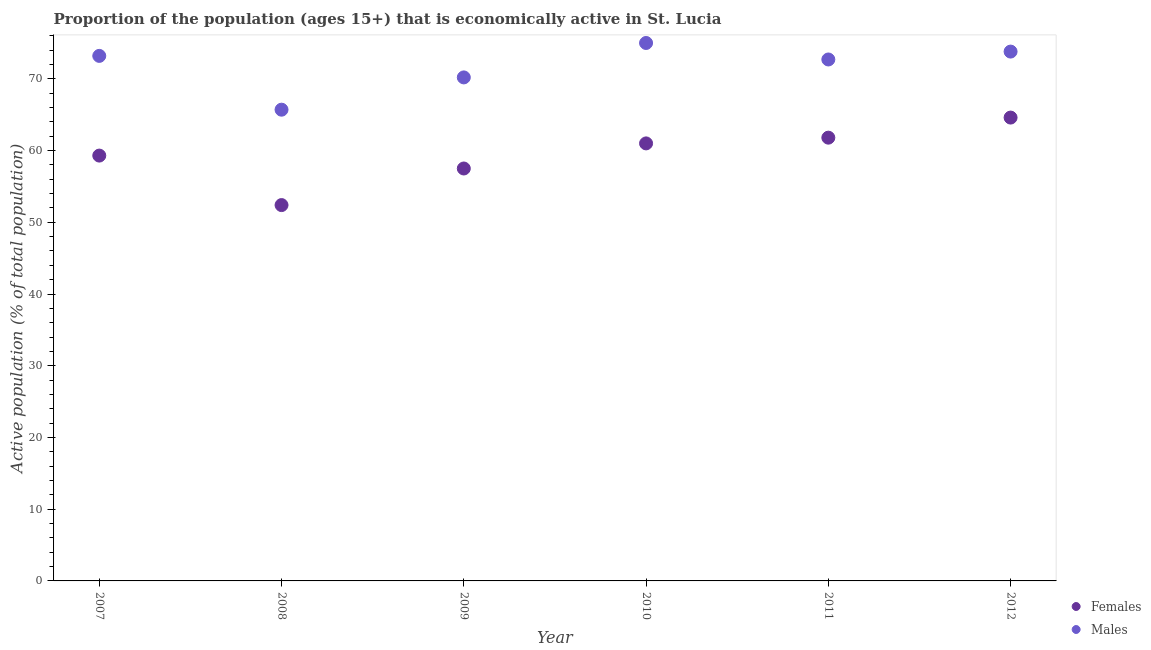How many different coloured dotlines are there?
Ensure brevity in your answer.  2. Is the number of dotlines equal to the number of legend labels?
Offer a very short reply. Yes. What is the percentage of economically active male population in 2007?
Your answer should be compact. 73.2. Across all years, what is the maximum percentage of economically active male population?
Keep it short and to the point. 75. Across all years, what is the minimum percentage of economically active female population?
Your answer should be compact. 52.4. What is the total percentage of economically active female population in the graph?
Provide a succinct answer. 356.6. What is the difference between the percentage of economically active male population in 2009 and that in 2012?
Make the answer very short. -3.6. What is the difference between the percentage of economically active male population in 2011 and the percentage of economically active female population in 2009?
Your response must be concise. 15.2. What is the average percentage of economically active male population per year?
Your response must be concise. 71.77. In the year 2009, what is the difference between the percentage of economically active male population and percentage of economically active female population?
Your answer should be compact. 12.7. In how many years, is the percentage of economically active male population greater than 16 %?
Ensure brevity in your answer.  6. What is the ratio of the percentage of economically active male population in 2010 to that in 2012?
Your answer should be very brief. 1.02. Is the percentage of economically active male population in 2009 less than that in 2012?
Offer a very short reply. Yes. Is the difference between the percentage of economically active male population in 2007 and 2011 greater than the difference between the percentage of economically active female population in 2007 and 2011?
Keep it short and to the point. Yes. What is the difference between the highest and the second highest percentage of economically active female population?
Ensure brevity in your answer.  2.8. What is the difference between the highest and the lowest percentage of economically active female population?
Provide a short and direct response. 12.2. Is the sum of the percentage of economically active male population in 2007 and 2011 greater than the maximum percentage of economically active female population across all years?
Offer a terse response. Yes. Does the percentage of economically active male population monotonically increase over the years?
Keep it short and to the point. No. Is the percentage of economically active male population strictly less than the percentage of economically active female population over the years?
Your response must be concise. No. How many dotlines are there?
Make the answer very short. 2. How many years are there in the graph?
Make the answer very short. 6. What is the difference between two consecutive major ticks on the Y-axis?
Give a very brief answer. 10. Are the values on the major ticks of Y-axis written in scientific E-notation?
Provide a succinct answer. No. Does the graph contain grids?
Keep it short and to the point. No. How are the legend labels stacked?
Offer a very short reply. Vertical. What is the title of the graph?
Provide a succinct answer. Proportion of the population (ages 15+) that is economically active in St. Lucia. What is the label or title of the Y-axis?
Provide a short and direct response. Active population (% of total population). What is the Active population (% of total population) in Females in 2007?
Offer a terse response. 59.3. What is the Active population (% of total population) of Males in 2007?
Your response must be concise. 73.2. What is the Active population (% of total population) of Females in 2008?
Offer a very short reply. 52.4. What is the Active population (% of total population) in Males in 2008?
Give a very brief answer. 65.7. What is the Active population (% of total population) in Females in 2009?
Your answer should be compact. 57.5. What is the Active population (% of total population) of Males in 2009?
Offer a very short reply. 70.2. What is the Active population (% of total population) of Females in 2010?
Provide a short and direct response. 61. What is the Active population (% of total population) in Females in 2011?
Offer a terse response. 61.8. What is the Active population (% of total population) of Males in 2011?
Provide a succinct answer. 72.7. What is the Active population (% of total population) of Females in 2012?
Provide a succinct answer. 64.6. What is the Active population (% of total population) in Males in 2012?
Your answer should be very brief. 73.8. Across all years, what is the maximum Active population (% of total population) in Females?
Provide a succinct answer. 64.6. Across all years, what is the minimum Active population (% of total population) of Females?
Offer a very short reply. 52.4. Across all years, what is the minimum Active population (% of total population) in Males?
Make the answer very short. 65.7. What is the total Active population (% of total population) of Females in the graph?
Your response must be concise. 356.6. What is the total Active population (% of total population) in Males in the graph?
Provide a succinct answer. 430.6. What is the difference between the Active population (% of total population) in Females in 2007 and that in 2008?
Make the answer very short. 6.9. What is the difference between the Active population (% of total population) in Females in 2007 and that in 2009?
Keep it short and to the point. 1.8. What is the difference between the Active population (% of total population) in Females in 2007 and that in 2010?
Your answer should be very brief. -1.7. What is the difference between the Active population (% of total population) in Males in 2007 and that in 2010?
Your answer should be compact. -1.8. What is the difference between the Active population (% of total population) in Females in 2007 and that in 2011?
Your response must be concise. -2.5. What is the difference between the Active population (% of total population) of Males in 2007 and that in 2011?
Provide a succinct answer. 0.5. What is the difference between the Active population (% of total population) in Females in 2007 and that in 2012?
Offer a very short reply. -5.3. What is the difference between the Active population (% of total population) in Females in 2008 and that in 2009?
Your answer should be very brief. -5.1. What is the difference between the Active population (% of total population) in Females in 2008 and that in 2010?
Give a very brief answer. -8.6. What is the difference between the Active population (% of total population) of Females in 2008 and that in 2011?
Your response must be concise. -9.4. What is the difference between the Active population (% of total population) in Males in 2009 and that in 2010?
Your answer should be very brief. -4.8. What is the difference between the Active population (% of total population) of Females in 2009 and that in 2011?
Provide a succinct answer. -4.3. What is the difference between the Active population (% of total population) in Females in 2009 and that in 2012?
Give a very brief answer. -7.1. What is the difference between the Active population (% of total population) of Females in 2010 and that in 2011?
Ensure brevity in your answer.  -0.8. What is the difference between the Active population (% of total population) in Males in 2010 and that in 2012?
Provide a short and direct response. 1.2. What is the difference between the Active population (% of total population) of Females in 2011 and that in 2012?
Provide a short and direct response. -2.8. What is the difference between the Active population (% of total population) of Females in 2007 and the Active population (% of total population) of Males in 2008?
Your response must be concise. -6.4. What is the difference between the Active population (% of total population) in Females in 2007 and the Active population (% of total population) in Males in 2010?
Offer a very short reply. -15.7. What is the difference between the Active population (% of total population) in Females in 2008 and the Active population (% of total population) in Males in 2009?
Keep it short and to the point. -17.8. What is the difference between the Active population (% of total population) of Females in 2008 and the Active population (% of total population) of Males in 2010?
Ensure brevity in your answer.  -22.6. What is the difference between the Active population (% of total population) in Females in 2008 and the Active population (% of total population) in Males in 2011?
Give a very brief answer. -20.3. What is the difference between the Active population (% of total population) in Females in 2008 and the Active population (% of total population) in Males in 2012?
Your answer should be compact. -21.4. What is the difference between the Active population (% of total population) of Females in 2009 and the Active population (% of total population) of Males in 2010?
Keep it short and to the point. -17.5. What is the difference between the Active population (% of total population) in Females in 2009 and the Active population (% of total population) in Males in 2011?
Your answer should be compact. -15.2. What is the difference between the Active population (% of total population) of Females in 2009 and the Active population (% of total population) of Males in 2012?
Ensure brevity in your answer.  -16.3. What is the difference between the Active population (% of total population) in Females in 2010 and the Active population (% of total population) in Males in 2012?
Ensure brevity in your answer.  -12.8. What is the difference between the Active population (% of total population) in Females in 2011 and the Active population (% of total population) in Males in 2012?
Your answer should be very brief. -12. What is the average Active population (% of total population) of Females per year?
Keep it short and to the point. 59.43. What is the average Active population (% of total population) of Males per year?
Your answer should be compact. 71.77. In the year 2008, what is the difference between the Active population (% of total population) in Females and Active population (% of total population) in Males?
Ensure brevity in your answer.  -13.3. In the year 2010, what is the difference between the Active population (% of total population) in Females and Active population (% of total population) in Males?
Provide a succinct answer. -14. What is the ratio of the Active population (% of total population) in Females in 2007 to that in 2008?
Your response must be concise. 1.13. What is the ratio of the Active population (% of total population) of Males in 2007 to that in 2008?
Your answer should be very brief. 1.11. What is the ratio of the Active population (% of total population) of Females in 2007 to that in 2009?
Give a very brief answer. 1.03. What is the ratio of the Active population (% of total population) of Males in 2007 to that in 2009?
Ensure brevity in your answer.  1.04. What is the ratio of the Active population (% of total population) of Females in 2007 to that in 2010?
Ensure brevity in your answer.  0.97. What is the ratio of the Active population (% of total population) of Males in 2007 to that in 2010?
Offer a very short reply. 0.98. What is the ratio of the Active population (% of total population) in Females in 2007 to that in 2011?
Give a very brief answer. 0.96. What is the ratio of the Active population (% of total population) in Females in 2007 to that in 2012?
Your answer should be very brief. 0.92. What is the ratio of the Active population (% of total population) in Males in 2007 to that in 2012?
Keep it short and to the point. 0.99. What is the ratio of the Active population (% of total population) in Females in 2008 to that in 2009?
Make the answer very short. 0.91. What is the ratio of the Active population (% of total population) of Males in 2008 to that in 2009?
Provide a short and direct response. 0.94. What is the ratio of the Active population (% of total population) of Females in 2008 to that in 2010?
Keep it short and to the point. 0.86. What is the ratio of the Active population (% of total population) of Males in 2008 to that in 2010?
Offer a terse response. 0.88. What is the ratio of the Active population (% of total population) in Females in 2008 to that in 2011?
Offer a very short reply. 0.85. What is the ratio of the Active population (% of total population) in Males in 2008 to that in 2011?
Keep it short and to the point. 0.9. What is the ratio of the Active population (% of total population) of Females in 2008 to that in 2012?
Provide a short and direct response. 0.81. What is the ratio of the Active population (% of total population) in Males in 2008 to that in 2012?
Your answer should be very brief. 0.89. What is the ratio of the Active population (% of total population) in Females in 2009 to that in 2010?
Make the answer very short. 0.94. What is the ratio of the Active population (% of total population) in Males in 2009 to that in 2010?
Provide a succinct answer. 0.94. What is the ratio of the Active population (% of total population) in Females in 2009 to that in 2011?
Your answer should be compact. 0.93. What is the ratio of the Active population (% of total population) in Males in 2009 to that in 2011?
Ensure brevity in your answer.  0.97. What is the ratio of the Active population (% of total population) of Females in 2009 to that in 2012?
Provide a short and direct response. 0.89. What is the ratio of the Active population (% of total population) in Males in 2009 to that in 2012?
Your response must be concise. 0.95. What is the ratio of the Active population (% of total population) of Females in 2010 to that in 2011?
Keep it short and to the point. 0.99. What is the ratio of the Active population (% of total population) in Males in 2010 to that in 2011?
Provide a short and direct response. 1.03. What is the ratio of the Active population (% of total population) of Females in 2010 to that in 2012?
Your answer should be compact. 0.94. What is the ratio of the Active population (% of total population) of Males in 2010 to that in 2012?
Your answer should be compact. 1.02. What is the ratio of the Active population (% of total population) in Females in 2011 to that in 2012?
Offer a terse response. 0.96. What is the ratio of the Active population (% of total population) in Males in 2011 to that in 2012?
Keep it short and to the point. 0.99. What is the difference between the highest and the second highest Active population (% of total population) in Females?
Ensure brevity in your answer.  2.8. What is the difference between the highest and the lowest Active population (% of total population) in Females?
Your answer should be compact. 12.2. What is the difference between the highest and the lowest Active population (% of total population) of Males?
Provide a succinct answer. 9.3. 